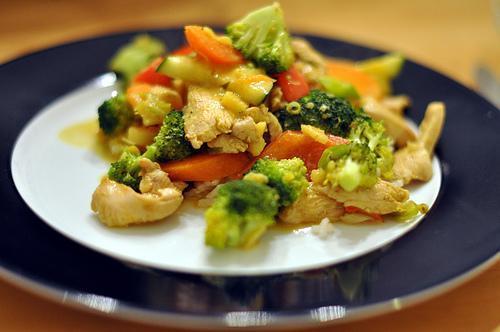How many utensils are pictured here?
Give a very brief answer. 1. How many people are in this picture?
Give a very brief answer. 0. 